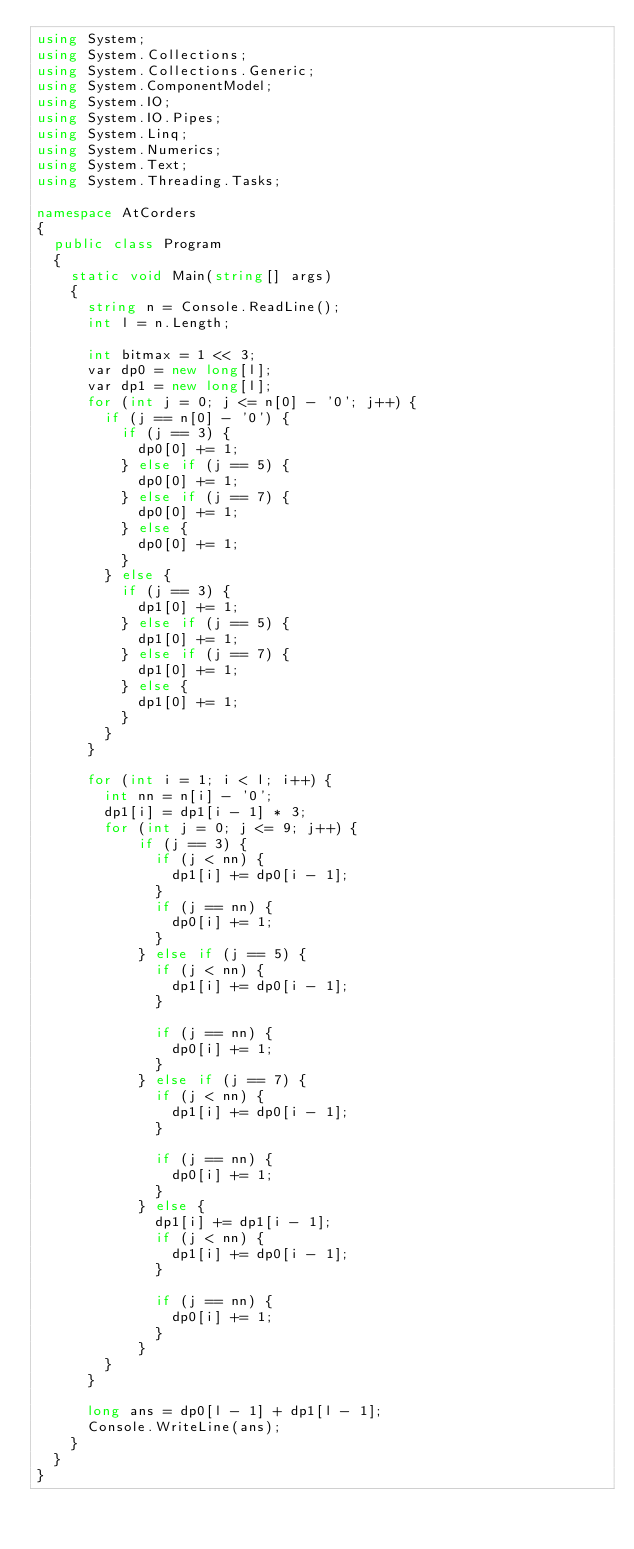<code> <loc_0><loc_0><loc_500><loc_500><_C#_>using System;
using System.Collections;
using System.Collections.Generic;
using System.ComponentModel;
using System.IO;
using System.IO.Pipes;
using System.Linq;
using System.Numerics;
using System.Text;
using System.Threading.Tasks;

namespace AtCorders
{
	public class Program
	{
		static void Main(string[] args)
		{
			string n = Console.ReadLine();
			int l = n.Length;

			int bitmax = 1 << 3;
			var dp0 = new long[l];
			var dp1 = new long[l];
			for (int j = 0; j <= n[0] - '0'; j++) {
				if (j == n[0] - '0') {
					if (j == 3) {
						dp0[0] += 1;
					} else if (j == 5) {
						dp0[0] += 1;
					} else if (j == 7) {
						dp0[0] += 1;
					} else {
						dp0[0] += 1;
					}
				} else {
					if (j == 3) {
						dp1[0] += 1;
					} else if (j == 5) {
						dp1[0] += 1;
					} else if (j == 7) {
						dp1[0] += 1;
					} else {
						dp1[0] += 1;
					}
				}
			}

			for (int i = 1; i < l; i++) {
				int nn = n[i] - '0';
				dp1[i] = dp1[i - 1] * 3;
				for (int j = 0; j <= 9; j++) {
						if (j == 3) {
							if (j < nn) {
								dp1[i] += dp0[i - 1];
							}
							if (j == nn) {
								dp0[i] += 1;
							}
						} else if (j == 5) {
							if (j < nn) {
								dp1[i] += dp0[i - 1];
							}

							if (j == nn) {
								dp0[i] += 1;
							}
						} else if (j == 7) {
							if (j < nn) {
								dp1[i] += dp0[i - 1];
							}

							if (j == nn) {
								dp0[i] += 1;
							}
						} else {
							dp1[i] += dp1[i - 1];
							if (j < nn) {
								dp1[i] += dp0[i - 1];
							}

							if (j == nn) {
								dp0[i] += 1;
							}
						}
				}
			}

			long ans = dp0[l - 1] + dp1[l - 1];
			Console.WriteLine(ans);
		}
	}
}</code> 